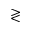Convert formula to latex. <formula><loc_0><loc_0><loc_500><loc_500>\gtrless</formula> 